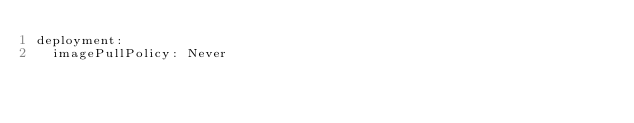<code> <loc_0><loc_0><loc_500><loc_500><_YAML_>deployment:
  imagePullPolicy: Never
</code> 